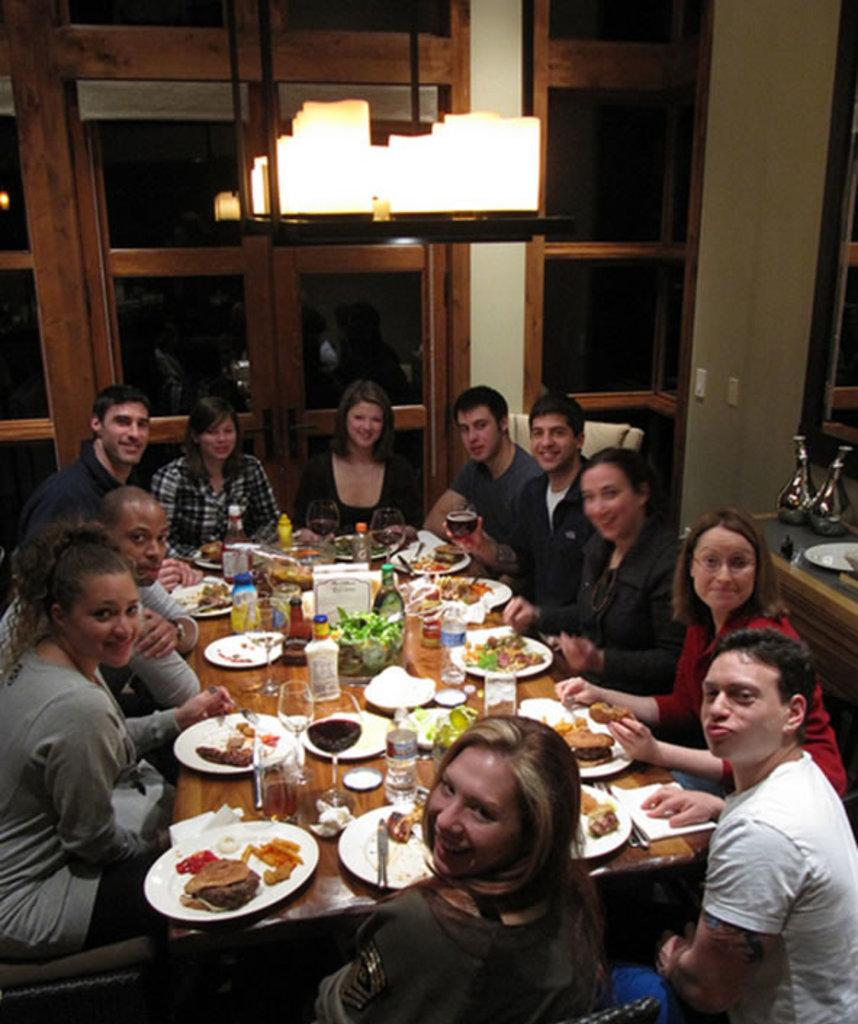What are the people in the image doing? The people in the image are sitting on chairs. What is present on the table in the image? There is a table in the image, and on it, there are glasses and plates. What riddle: What has a head and a tail, but no body? The image does not contain a riddle or any object that has a head and a tail but no body. 